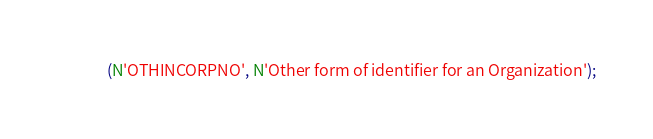<code> <loc_0><loc_0><loc_500><loc_500><_SQL_>  (N'OTHINCORPNO', N'Other form of identifier for an Organization');
</code> 